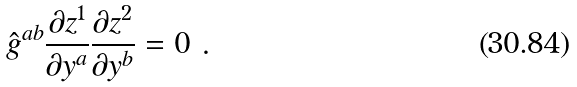<formula> <loc_0><loc_0><loc_500><loc_500>\hat { g } ^ { a b } \frac { \partial z ^ { 1 } } { \partial y ^ { a } } \frac { \partial z ^ { 2 } } { \partial y ^ { b } } = 0 \ .</formula> 